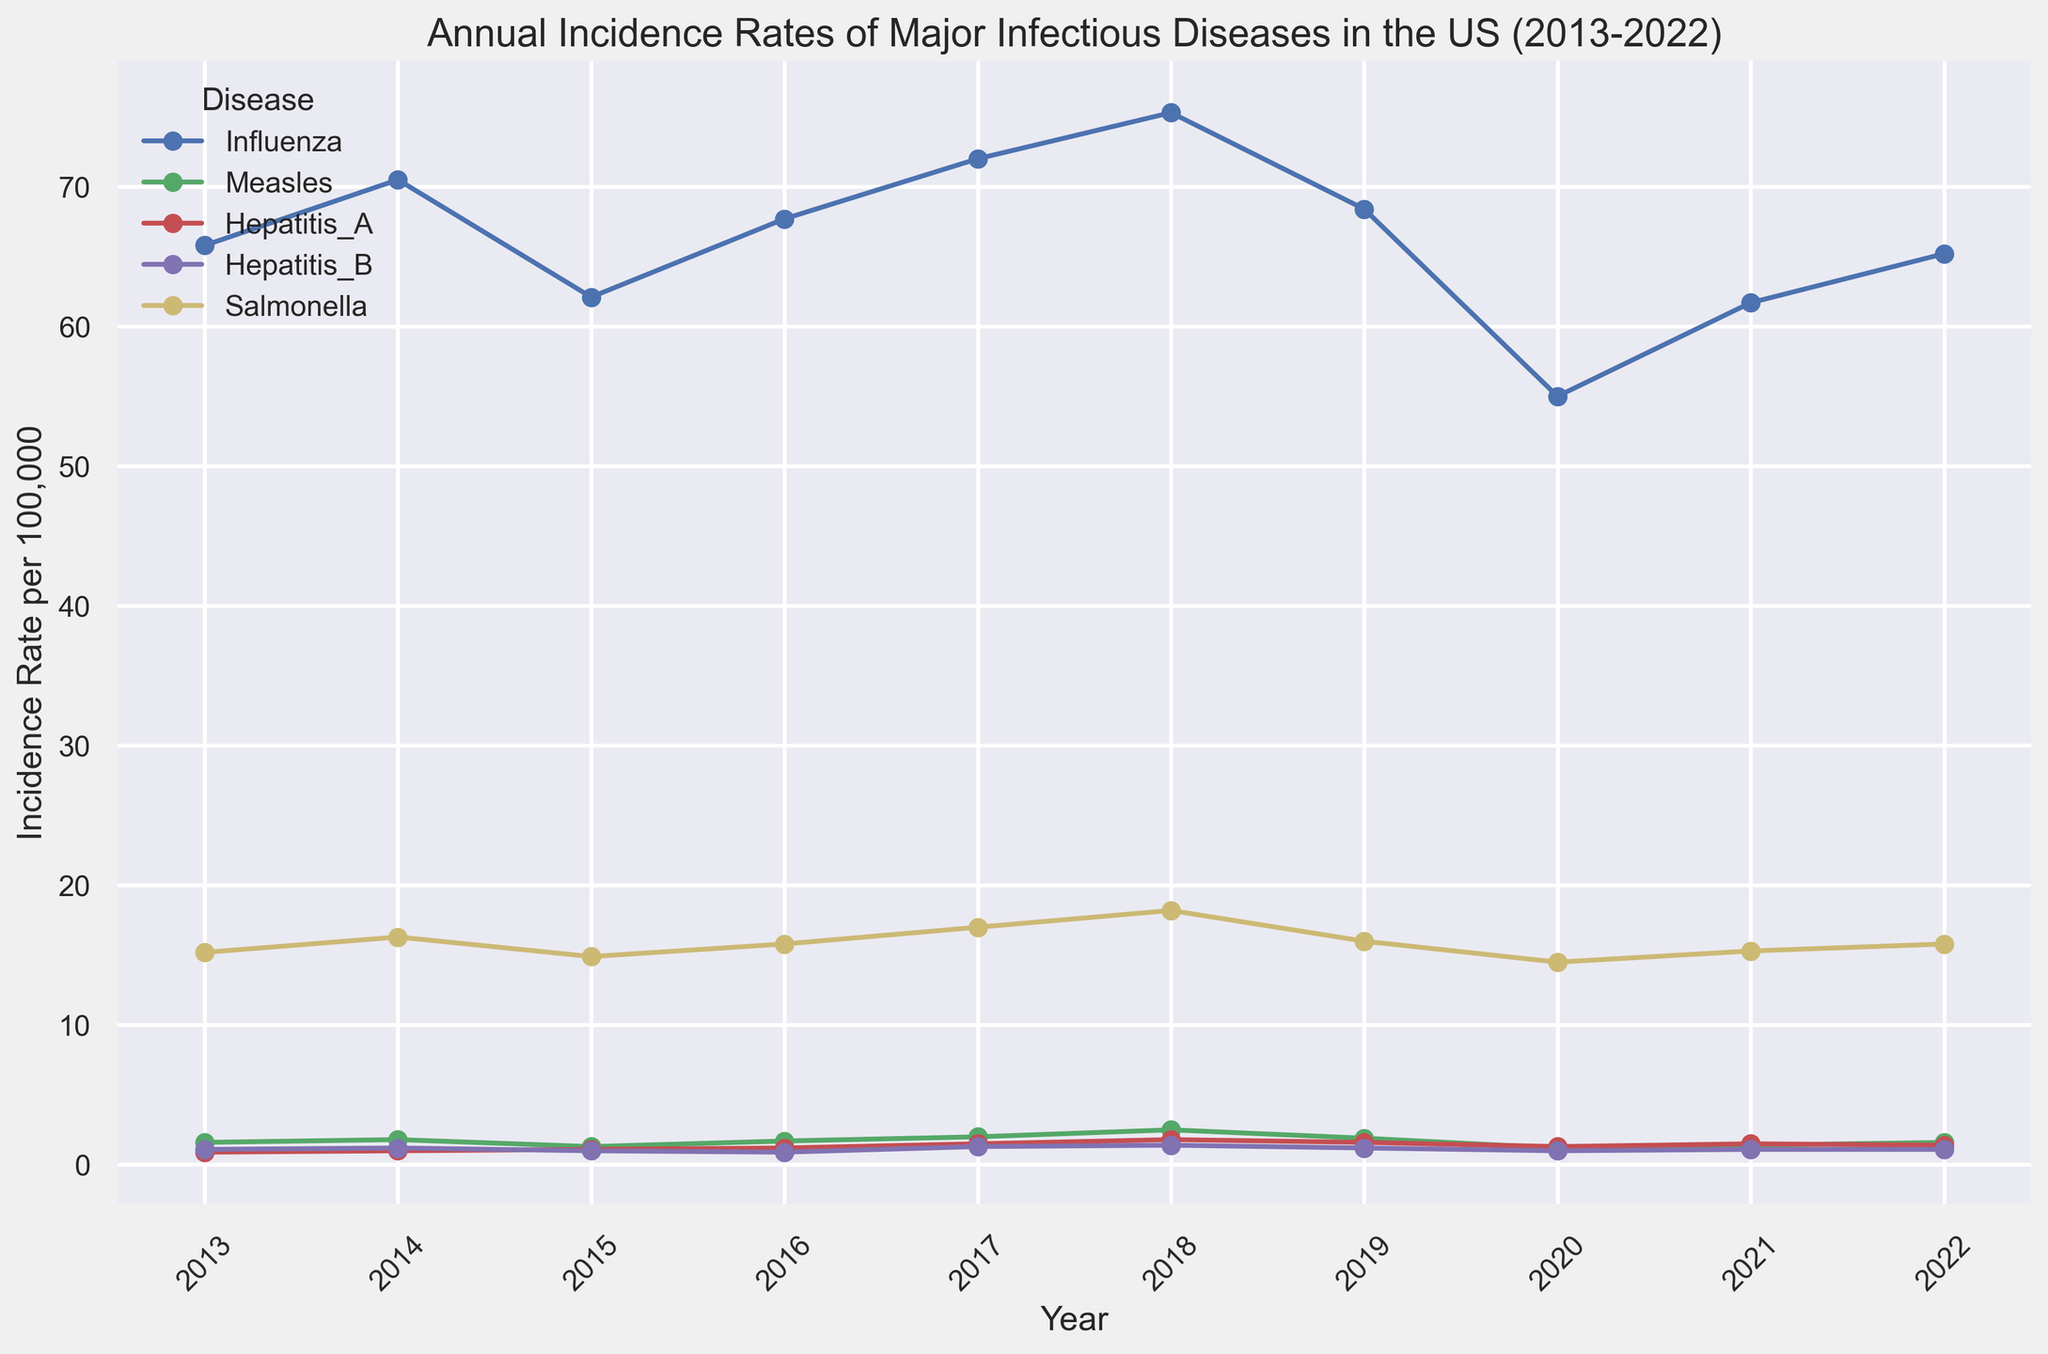Which disease had the highest incidence rate in 2018? Look at the lines for the year 2018 and identify which disease line reaches the highest point on the y-axis. Influenza’s line is at 75.3, which is the highest incidence rate for that year.
Answer: Influenza Between 2014 and 2016, how did the incidence rate of Measles change? Examine the points for Measles in the years 2014 and 2016. In 2014, the incidence rate was 1.8, and in 2016 it increased to 1.7. The change equals 1.7 - 1.8 = -0.1. This shows that the incidence rate slightly decreased.
Answer: Decreased by 0.1 What is the total incidence rate of Salmonella in 2019 and 2020 combined? Find the data points for Salmonella in 2019 (16.0) and 2020 (14.5). Sum these values: 16.0 + 14.5 = 30.5.
Answer: 30.5 Did the incidence rate of Hepatitis A increase, decrease, or remain constant from 2021 to 2022? Observe the points for Hepatitis A in 2021 and 2022. In 2021, the incidence rate was 1.5, and it decreased to 1.4 in 2022. This shows a decrease.
Answer: Decreased In which year was the incidence rate of influenza the lowest? Identify the lowest point of the Influenza line across all years. The lowest point is in 2020, with an incidence rate of 55.0.
Answer: 2020 What is the average incidence rate of Measles from 2017 to 2019? Find the incidence rates for Measles in 2017, 2018, and 2019. They are 2.0, 2.5, and 1.9, respectively. Add these values and divide by 3: (2.0 + 2.5 + 1.9)/3 = 2.13.
Answer: 2.13 Which disease generally had the most stable incidence rate over the past decade? Look at each disease’s line and consider their fluctuations. Hepatitis B’s line shows the least fluctuation, remaining mostly around 1.0-1.3, indicating the most stable incidence rate.
Answer: Hepatitis B How did the incidence rate of Salmonella change from 2013 to 2018? Analyze the data points for Salmonella in 2013 and 2018. In 2013, the incidence rate was 15.2, and in 2018 it increased to 18.2. The change is 18.2 - 15.2 = 3.0.
Answer: Increased by 3.0 Which disease had a lower incidence rate: Hepatitis A in 2015 or Measles in 2015? Compare the incidence rates for Hepatitis A (1.1) and Measles (1.3) in 2015. Hepatitis A’s rate is lower.
Answer: Hepatitis A What was the trend in Influenza incidence rates from 2016 to 2020? Identify the incidence rates of Influenza from 2016 (67.7) to 2020 (55.0) and observe the trend. The rates decreased year by year reaching the lowest in 2020.
Answer: Decreasing trend 